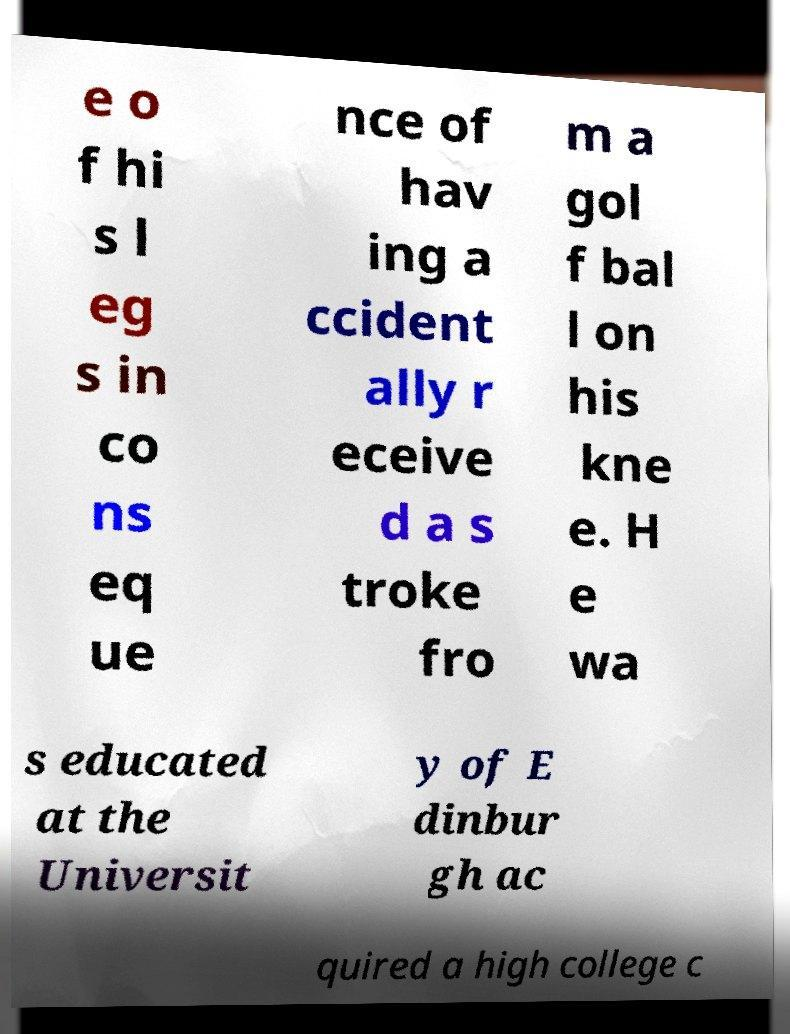I need the written content from this picture converted into text. Can you do that? e o f hi s l eg s in co ns eq ue nce of hav ing a ccident ally r eceive d a s troke fro m a gol f bal l on his kne e. H e wa s educated at the Universit y of E dinbur gh ac quired a high college c 